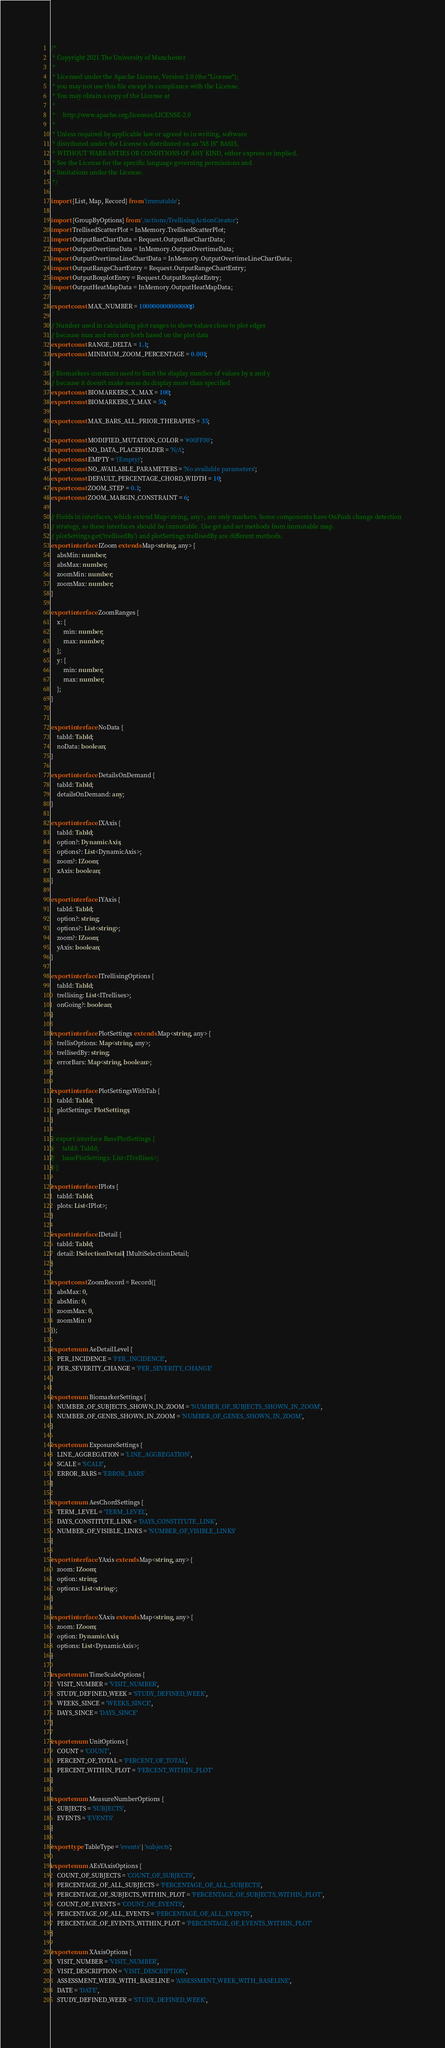<code> <loc_0><loc_0><loc_500><loc_500><_TypeScript_>/*
 * Copyright 2021 The University of Manchester
 *
 * Licensed under the Apache License, Version 2.0 (the "License");
 * you may not use this file except in compliance with the License.
 * You may obtain a copy of the License at
 *
 *     http://www.apache.org/licenses/LICENSE-2.0
 *
 * Unless required by applicable law or agreed to in writing, software
 * distributed under the License is distributed on an "AS IS" BASIS,
 * WITHOUT WARRANTIES OR CONDITIONS OF ANY KIND, either express or implied.
 * See the License for the specific language governing permissions and
 * limitations under the License.
 */

import {List, Map, Record} from 'immutable';

import {GroupByOptions} from './actions/TrellisingActionCreator';
import TrellisedScatterPlot = InMemory.TrellisedScatterPlot;
import OutputBarChartData = Request.OutputBarChartData;
import OutputOvertimeData = InMemory.OutputOvertimeData;
import OutputOvertimeLineChartData = InMemory.OutputOvertimeLineChartData;
import OutputRangeChartEntry = Request.OutputRangeChartEntry;
import OutputBoxplotEntry = Request.OutputBoxplotEntry;
import OutputHeatMapData = InMemory.OutputHeatMapData;

export const MAX_NUMBER = 1000000000000000;

// Number used in calculating plot ranges to show values close to plot edges
// because max and min are both based on the plot data
export const RANGE_DELTA = 1.1;
export const MINIMUM_ZOOM_PERCENTAGE = 0.001;

// Biomarkers constants used to limit the display number of values by x and y
// because it doesn't make sense do display more than specified
export const BIOMARKERS_X_MAX = 100;
export const BIOMARKERS_Y_MAX = 50;

export const MAX_BARS_ALL_PRIOR_THERAPIES = 35;

export const MODIFIED_MUTATION_COLOR = '#00FF00';
export const NO_DATA_PLACEHOLDER = 'N/A';
export const EMPTY = '(Empty)';
export const NO_AVAILABLE_PARAMETERS = 'No available parameters';
export const DEFAULT_PERCENTAGE_CHORD_WIDTH = 10;
export const ZOOM_STEP = 0.1;
export const ZOOM_MARGIN_CONSTRAINT = 6;

// Fields in interfaces, which extend Map<string, any>, are only markers. Some components have OnPush change detection
// strategy, so these interfaces should be immutable. Use get and set methods from immutable map.
// plotSettings.get('trellisedBy') and plotSettings.trellisedBy are different methods.
export interface IZoom extends Map<string, any> {
    absMin: number;
    absMax: number;
    zoomMin: number;
    zoomMax: number;
}

export interface ZoomRanges {
    x: {
        min: number;
        max: number;
    };
    y: {
        min: number;
        max: number;
    };
}


export interface NoData {
    tabId: TabId;
    noData: boolean;
}

export interface DetailsOnDemand {
    tabId: TabId;
    detailsOnDemand: any;
}

export interface IXAxis {
    tabId: TabId;
    option?: DynamicAxis;
    options?: List<DynamicAxis>;
    zoom?: IZoom;
    xAxis: boolean;
}

export interface IYAxis {
    tabId: TabId;
    option?: string;
    options?: List<string>;
    zoom?: IZoom;
    yAxis: boolean;
}

export interface ITrellisingOptions {
    tabId: TabId;
    trellising: List<ITrellises>;
    onGoing?: boolean;
}

export interface PlotSettings extends Map<string, any> {
    trellisOptions: Map<string, any>;
    trellisedBy: string;
    errorBars: Map<string, boolean>;
}

export interface PlotSettingsWithTab {
    tabId: TabId;
    plotSettings: PlotSettings;
}

// export interface BasePlotSettings {
//     tabId: TabId;
//     basePlotSettings: List<ITrellises>;
// }

export interface IPlots {
    tabId: TabId;
    plots: List<IPlot>;
}

export interface IDetail {
    tabId: TabId;
    detail: ISelectionDetail | IMultiSelectionDetail;
}

export const ZoomRecord = Record({
    absMax: 0,
    absMin: 0,
    zoomMax: 0,
    zoomMin: 0
});

export enum AeDetailLevel {
    PER_INCIDENCE = 'PER_INCIDENCE',
    PER_SEVERITY_CHANGE = 'PER_SEVERITY_CHANGE'
}

export enum BiomarkerSettings {
    NUMBER_OF_SUBJECTS_SHOWN_IN_ZOOM = 'NUMBER_OF_SUBJECTS_SHOWN_IN_ZOOM',
    NUMBER_OF_GENES_SHOWN_IN_ZOOM = 'NUMBER_OF_GENES_SHOWN_IN_ZOOM',
}

export enum ExposureSettings {
    LINE_AGGREGATION = 'LINE_AGGREGATION',
    SCALE = 'SCALE',
    ERROR_BARS = 'ERROR_BARS'
}

export enum AesChordSettings {
    TERM_LEVEL = 'TERM_LEVEL',
    DAYS_CONSTITUTE_LINK = 'DAYS_CONSTITUTE_LINK',
    NUMBER_OF_VISIBLE_LINKS = 'NUMBER_OF_VISIBLE_LINKS'
}

export interface YAxis extends Map<string, any> {
    zoom: IZoom;
    option: string;
    options: List<string>;
}

export interface XAxis extends Map<string, any> {
    zoom: IZoom;
    option: DynamicAxis;
    options: List<DynamicAxis>;
}

export enum TimeScaleOptions {
    VISIT_NUMBER = 'VISIT_NUMBER',
    STUDY_DEFINED_WEEK = 'STUDY_DEFINED_WEEK',
    WEEKS_SINCE = 'WEEKS_SINCE',
    DAYS_SINCE = 'DAYS_SINCE'
}

export enum UnitOptions {
    COUNT = 'COUNT',
    PERCENT_OF_TOTAL = 'PERCENT_OF_TOTAL',
    PERCENT_WITHIN_PLOT = 'PERCENT_WITHIN_PLOT'
}

export enum MeasureNumberOptions {
    SUBJECTS = 'SUBJECTS',
    EVENTS = 'EVENTS'
}

export type TableType = 'events' | 'subjects';

export enum AEsYAxisOptions {
    COUNT_OF_SUBJECTS = 'COUNT_OF_SUBJECTS',
    PERCENTAGE_OF_ALL_SUBJECTS = 'PERCENTAGE_OF_ALL_SUBJECTS',
    PERCENTAGE_OF_SUBJECTS_WITHIN_PLOT = 'PERCENTAGE_OF_SUBJECTS_WITHIN_PLOT',
    COUNT_OF_EVENTS = 'COUNT_OF_EVENTS',
    PERCENTAGE_OF_ALL_EVENTS = 'PERCENTAGE_OF_ALL_EVENTS',
    PERCENTAGE_OF_EVENTS_WITHIN_PLOT = 'PERCENTAGE_OF_EVENTS_WITHIN_PLOT'
}

export enum XAxisOptions {
    VISIT_NUMBER = 'VISIT_NUMBER',
    VISIT_DESCRIPTION = 'VISIT_DESCRIPTION',
    ASSESSMENT_WEEK_WITH_BASELINE = 'ASSESSMENT_WEEK_WITH_BASELINE',
    DATE = 'DATE',
    STUDY_DEFINED_WEEK = 'STUDY_DEFINED_WEEK',</code> 